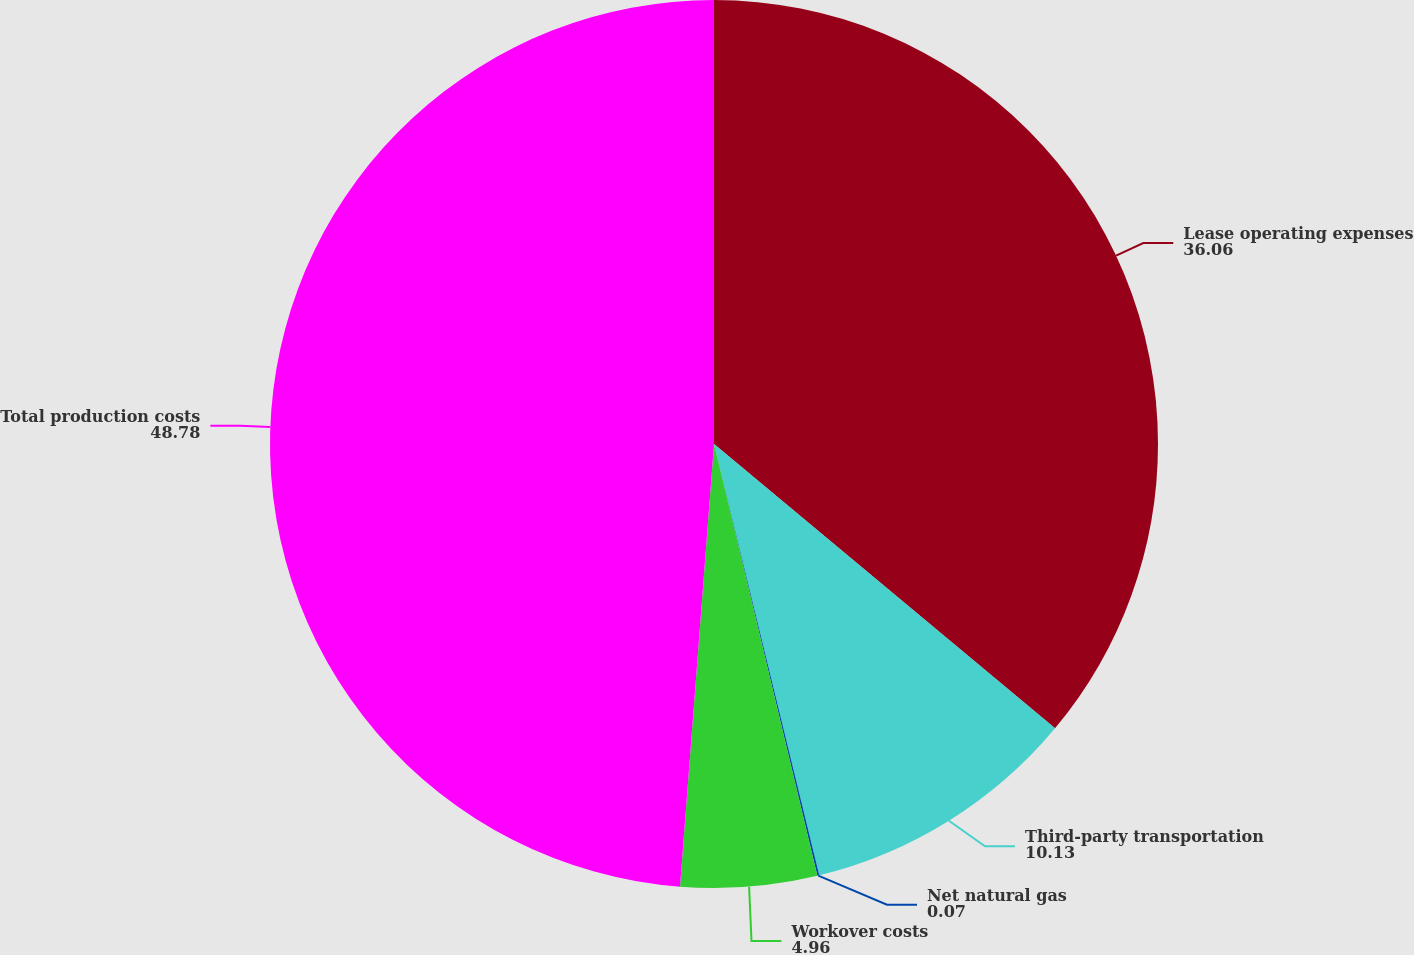Convert chart. <chart><loc_0><loc_0><loc_500><loc_500><pie_chart><fcel>Lease operating expenses<fcel>Third-party transportation<fcel>Net natural gas<fcel>Workover costs<fcel>Total production costs<nl><fcel>36.06%<fcel>10.13%<fcel>0.07%<fcel>4.96%<fcel>48.78%<nl></chart> 